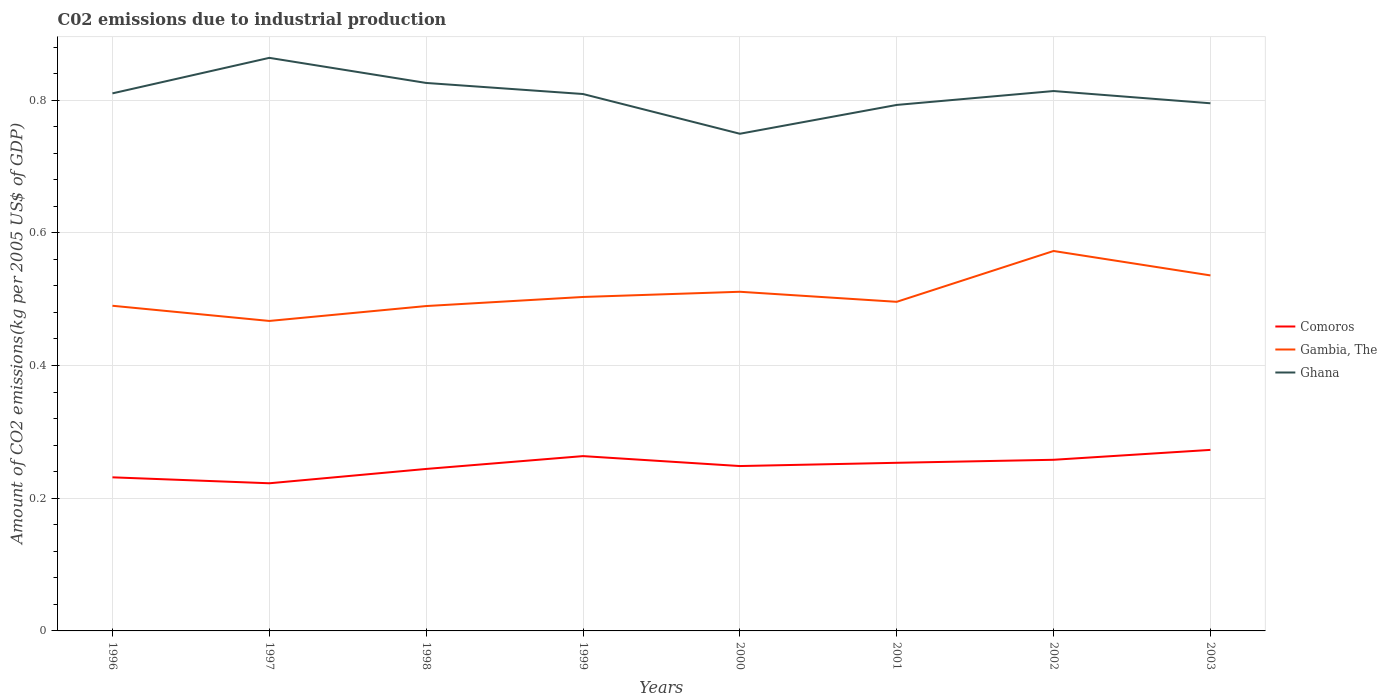How many different coloured lines are there?
Provide a short and direct response. 3. Across all years, what is the maximum amount of CO2 emitted due to industrial production in Ghana?
Give a very brief answer. 0.75. What is the total amount of CO2 emitted due to industrial production in Ghana in the graph?
Provide a succinct answer. -0. What is the difference between the highest and the second highest amount of CO2 emitted due to industrial production in Comoros?
Your response must be concise. 0.05. What is the difference between the highest and the lowest amount of CO2 emitted due to industrial production in Gambia, The?
Ensure brevity in your answer.  3. Does the graph contain grids?
Ensure brevity in your answer.  Yes. How many legend labels are there?
Your answer should be compact. 3. How are the legend labels stacked?
Your answer should be compact. Vertical. What is the title of the graph?
Give a very brief answer. C02 emissions due to industrial production. Does "Tuvalu" appear as one of the legend labels in the graph?
Make the answer very short. No. What is the label or title of the X-axis?
Your answer should be very brief. Years. What is the label or title of the Y-axis?
Keep it short and to the point. Amount of CO2 emissions(kg per 2005 US$ of GDP). What is the Amount of CO2 emissions(kg per 2005 US$ of GDP) in Comoros in 1996?
Offer a terse response. 0.23. What is the Amount of CO2 emissions(kg per 2005 US$ of GDP) in Gambia, The in 1996?
Your answer should be very brief. 0.49. What is the Amount of CO2 emissions(kg per 2005 US$ of GDP) in Ghana in 1996?
Give a very brief answer. 0.81. What is the Amount of CO2 emissions(kg per 2005 US$ of GDP) of Comoros in 1997?
Your answer should be compact. 0.22. What is the Amount of CO2 emissions(kg per 2005 US$ of GDP) of Gambia, The in 1997?
Your answer should be very brief. 0.47. What is the Amount of CO2 emissions(kg per 2005 US$ of GDP) in Ghana in 1997?
Your answer should be compact. 0.86. What is the Amount of CO2 emissions(kg per 2005 US$ of GDP) in Comoros in 1998?
Make the answer very short. 0.24. What is the Amount of CO2 emissions(kg per 2005 US$ of GDP) of Gambia, The in 1998?
Offer a terse response. 0.49. What is the Amount of CO2 emissions(kg per 2005 US$ of GDP) in Ghana in 1998?
Offer a very short reply. 0.83. What is the Amount of CO2 emissions(kg per 2005 US$ of GDP) of Comoros in 1999?
Ensure brevity in your answer.  0.26. What is the Amount of CO2 emissions(kg per 2005 US$ of GDP) of Gambia, The in 1999?
Provide a succinct answer. 0.5. What is the Amount of CO2 emissions(kg per 2005 US$ of GDP) of Ghana in 1999?
Keep it short and to the point. 0.81. What is the Amount of CO2 emissions(kg per 2005 US$ of GDP) in Comoros in 2000?
Keep it short and to the point. 0.25. What is the Amount of CO2 emissions(kg per 2005 US$ of GDP) of Gambia, The in 2000?
Your response must be concise. 0.51. What is the Amount of CO2 emissions(kg per 2005 US$ of GDP) of Ghana in 2000?
Give a very brief answer. 0.75. What is the Amount of CO2 emissions(kg per 2005 US$ of GDP) in Comoros in 2001?
Ensure brevity in your answer.  0.25. What is the Amount of CO2 emissions(kg per 2005 US$ of GDP) in Gambia, The in 2001?
Provide a succinct answer. 0.5. What is the Amount of CO2 emissions(kg per 2005 US$ of GDP) in Ghana in 2001?
Ensure brevity in your answer.  0.79. What is the Amount of CO2 emissions(kg per 2005 US$ of GDP) of Comoros in 2002?
Offer a terse response. 0.26. What is the Amount of CO2 emissions(kg per 2005 US$ of GDP) in Gambia, The in 2002?
Your answer should be compact. 0.57. What is the Amount of CO2 emissions(kg per 2005 US$ of GDP) of Ghana in 2002?
Provide a succinct answer. 0.81. What is the Amount of CO2 emissions(kg per 2005 US$ of GDP) in Comoros in 2003?
Provide a succinct answer. 0.27. What is the Amount of CO2 emissions(kg per 2005 US$ of GDP) of Gambia, The in 2003?
Provide a short and direct response. 0.54. What is the Amount of CO2 emissions(kg per 2005 US$ of GDP) of Ghana in 2003?
Give a very brief answer. 0.8. Across all years, what is the maximum Amount of CO2 emissions(kg per 2005 US$ of GDP) of Comoros?
Provide a succinct answer. 0.27. Across all years, what is the maximum Amount of CO2 emissions(kg per 2005 US$ of GDP) in Gambia, The?
Keep it short and to the point. 0.57. Across all years, what is the maximum Amount of CO2 emissions(kg per 2005 US$ of GDP) of Ghana?
Keep it short and to the point. 0.86. Across all years, what is the minimum Amount of CO2 emissions(kg per 2005 US$ of GDP) of Comoros?
Your answer should be very brief. 0.22. Across all years, what is the minimum Amount of CO2 emissions(kg per 2005 US$ of GDP) of Gambia, The?
Make the answer very short. 0.47. Across all years, what is the minimum Amount of CO2 emissions(kg per 2005 US$ of GDP) of Ghana?
Offer a very short reply. 0.75. What is the total Amount of CO2 emissions(kg per 2005 US$ of GDP) in Comoros in the graph?
Your answer should be very brief. 1.99. What is the total Amount of CO2 emissions(kg per 2005 US$ of GDP) in Gambia, The in the graph?
Keep it short and to the point. 4.07. What is the total Amount of CO2 emissions(kg per 2005 US$ of GDP) of Ghana in the graph?
Offer a terse response. 6.46. What is the difference between the Amount of CO2 emissions(kg per 2005 US$ of GDP) in Comoros in 1996 and that in 1997?
Make the answer very short. 0.01. What is the difference between the Amount of CO2 emissions(kg per 2005 US$ of GDP) in Gambia, The in 1996 and that in 1997?
Your answer should be very brief. 0.02. What is the difference between the Amount of CO2 emissions(kg per 2005 US$ of GDP) of Ghana in 1996 and that in 1997?
Provide a succinct answer. -0.05. What is the difference between the Amount of CO2 emissions(kg per 2005 US$ of GDP) of Comoros in 1996 and that in 1998?
Make the answer very short. -0.01. What is the difference between the Amount of CO2 emissions(kg per 2005 US$ of GDP) of Gambia, The in 1996 and that in 1998?
Offer a terse response. 0. What is the difference between the Amount of CO2 emissions(kg per 2005 US$ of GDP) of Ghana in 1996 and that in 1998?
Provide a succinct answer. -0.02. What is the difference between the Amount of CO2 emissions(kg per 2005 US$ of GDP) of Comoros in 1996 and that in 1999?
Provide a short and direct response. -0.03. What is the difference between the Amount of CO2 emissions(kg per 2005 US$ of GDP) in Gambia, The in 1996 and that in 1999?
Offer a terse response. -0.01. What is the difference between the Amount of CO2 emissions(kg per 2005 US$ of GDP) of Ghana in 1996 and that in 1999?
Ensure brevity in your answer.  0. What is the difference between the Amount of CO2 emissions(kg per 2005 US$ of GDP) in Comoros in 1996 and that in 2000?
Provide a short and direct response. -0.02. What is the difference between the Amount of CO2 emissions(kg per 2005 US$ of GDP) of Gambia, The in 1996 and that in 2000?
Offer a very short reply. -0.02. What is the difference between the Amount of CO2 emissions(kg per 2005 US$ of GDP) in Ghana in 1996 and that in 2000?
Your answer should be compact. 0.06. What is the difference between the Amount of CO2 emissions(kg per 2005 US$ of GDP) in Comoros in 1996 and that in 2001?
Offer a very short reply. -0.02. What is the difference between the Amount of CO2 emissions(kg per 2005 US$ of GDP) of Gambia, The in 1996 and that in 2001?
Provide a short and direct response. -0.01. What is the difference between the Amount of CO2 emissions(kg per 2005 US$ of GDP) in Ghana in 1996 and that in 2001?
Ensure brevity in your answer.  0.02. What is the difference between the Amount of CO2 emissions(kg per 2005 US$ of GDP) of Comoros in 1996 and that in 2002?
Give a very brief answer. -0.03. What is the difference between the Amount of CO2 emissions(kg per 2005 US$ of GDP) of Gambia, The in 1996 and that in 2002?
Give a very brief answer. -0.08. What is the difference between the Amount of CO2 emissions(kg per 2005 US$ of GDP) of Ghana in 1996 and that in 2002?
Your answer should be compact. -0. What is the difference between the Amount of CO2 emissions(kg per 2005 US$ of GDP) in Comoros in 1996 and that in 2003?
Give a very brief answer. -0.04. What is the difference between the Amount of CO2 emissions(kg per 2005 US$ of GDP) in Gambia, The in 1996 and that in 2003?
Provide a short and direct response. -0.05. What is the difference between the Amount of CO2 emissions(kg per 2005 US$ of GDP) of Ghana in 1996 and that in 2003?
Offer a very short reply. 0.01. What is the difference between the Amount of CO2 emissions(kg per 2005 US$ of GDP) in Comoros in 1997 and that in 1998?
Offer a terse response. -0.02. What is the difference between the Amount of CO2 emissions(kg per 2005 US$ of GDP) of Gambia, The in 1997 and that in 1998?
Offer a very short reply. -0.02. What is the difference between the Amount of CO2 emissions(kg per 2005 US$ of GDP) of Ghana in 1997 and that in 1998?
Provide a short and direct response. 0.04. What is the difference between the Amount of CO2 emissions(kg per 2005 US$ of GDP) of Comoros in 1997 and that in 1999?
Ensure brevity in your answer.  -0.04. What is the difference between the Amount of CO2 emissions(kg per 2005 US$ of GDP) of Gambia, The in 1997 and that in 1999?
Provide a succinct answer. -0.04. What is the difference between the Amount of CO2 emissions(kg per 2005 US$ of GDP) of Ghana in 1997 and that in 1999?
Your answer should be compact. 0.05. What is the difference between the Amount of CO2 emissions(kg per 2005 US$ of GDP) of Comoros in 1997 and that in 2000?
Your response must be concise. -0.03. What is the difference between the Amount of CO2 emissions(kg per 2005 US$ of GDP) of Gambia, The in 1997 and that in 2000?
Provide a succinct answer. -0.04. What is the difference between the Amount of CO2 emissions(kg per 2005 US$ of GDP) in Ghana in 1997 and that in 2000?
Offer a terse response. 0.11. What is the difference between the Amount of CO2 emissions(kg per 2005 US$ of GDP) in Comoros in 1997 and that in 2001?
Provide a succinct answer. -0.03. What is the difference between the Amount of CO2 emissions(kg per 2005 US$ of GDP) in Gambia, The in 1997 and that in 2001?
Offer a terse response. -0.03. What is the difference between the Amount of CO2 emissions(kg per 2005 US$ of GDP) in Ghana in 1997 and that in 2001?
Keep it short and to the point. 0.07. What is the difference between the Amount of CO2 emissions(kg per 2005 US$ of GDP) in Comoros in 1997 and that in 2002?
Keep it short and to the point. -0.04. What is the difference between the Amount of CO2 emissions(kg per 2005 US$ of GDP) of Gambia, The in 1997 and that in 2002?
Your answer should be compact. -0.11. What is the difference between the Amount of CO2 emissions(kg per 2005 US$ of GDP) of Ghana in 1997 and that in 2002?
Give a very brief answer. 0.05. What is the difference between the Amount of CO2 emissions(kg per 2005 US$ of GDP) in Comoros in 1997 and that in 2003?
Make the answer very short. -0.05. What is the difference between the Amount of CO2 emissions(kg per 2005 US$ of GDP) of Gambia, The in 1997 and that in 2003?
Your answer should be compact. -0.07. What is the difference between the Amount of CO2 emissions(kg per 2005 US$ of GDP) of Ghana in 1997 and that in 2003?
Your answer should be compact. 0.07. What is the difference between the Amount of CO2 emissions(kg per 2005 US$ of GDP) of Comoros in 1998 and that in 1999?
Offer a very short reply. -0.02. What is the difference between the Amount of CO2 emissions(kg per 2005 US$ of GDP) in Gambia, The in 1998 and that in 1999?
Offer a terse response. -0.01. What is the difference between the Amount of CO2 emissions(kg per 2005 US$ of GDP) in Ghana in 1998 and that in 1999?
Offer a terse response. 0.02. What is the difference between the Amount of CO2 emissions(kg per 2005 US$ of GDP) of Comoros in 1998 and that in 2000?
Ensure brevity in your answer.  -0. What is the difference between the Amount of CO2 emissions(kg per 2005 US$ of GDP) of Gambia, The in 1998 and that in 2000?
Make the answer very short. -0.02. What is the difference between the Amount of CO2 emissions(kg per 2005 US$ of GDP) in Ghana in 1998 and that in 2000?
Ensure brevity in your answer.  0.08. What is the difference between the Amount of CO2 emissions(kg per 2005 US$ of GDP) of Comoros in 1998 and that in 2001?
Keep it short and to the point. -0.01. What is the difference between the Amount of CO2 emissions(kg per 2005 US$ of GDP) of Gambia, The in 1998 and that in 2001?
Make the answer very short. -0.01. What is the difference between the Amount of CO2 emissions(kg per 2005 US$ of GDP) of Ghana in 1998 and that in 2001?
Ensure brevity in your answer.  0.03. What is the difference between the Amount of CO2 emissions(kg per 2005 US$ of GDP) of Comoros in 1998 and that in 2002?
Offer a terse response. -0.01. What is the difference between the Amount of CO2 emissions(kg per 2005 US$ of GDP) in Gambia, The in 1998 and that in 2002?
Offer a very short reply. -0.08. What is the difference between the Amount of CO2 emissions(kg per 2005 US$ of GDP) in Ghana in 1998 and that in 2002?
Keep it short and to the point. 0.01. What is the difference between the Amount of CO2 emissions(kg per 2005 US$ of GDP) of Comoros in 1998 and that in 2003?
Keep it short and to the point. -0.03. What is the difference between the Amount of CO2 emissions(kg per 2005 US$ of GDP) in Gambia, The in 1998 and that in 2003?
Ensure brevity in your answer.  -0.05. What is the difference between the Amount of CO2 emissions(kg per 2005 US$ of GDP) in Ghana in 1998 and that in 2003?
Offer a terse response. 0.03. What is the difference between the Amount of CO2 emissions(kg per 2005 US$ of GDP) of Comoros in 1999 and that in 2000?
Keep it short and to the point. 0.01. What is the difference between the Amount of CO2 emissions(kg per 2005 US$ of GDP) of Gambia, The in 1999 and that in 2000?
Your response must be concise. -0.01. What is the difference between the Amount of CO2 emissions(kg per 2005 US$ of GDP) of Ghana in 1999 and that in 2000?
Offer a very short reply. 0.06. What is the difference between the Amount of CO2 emissions(kg per 2005 US$ of GDP) in Comoros in 1999 and that in 2001?
Provide a short and direct response. 0.01. What is the difference between the Amount of CO2 emissions(kg per 2005 US$ of GDP) in Gambia, The in 1999 and that in 2001?
Your answer should be compact. 0.01. What is the difference between the Amount of CO2 emissions(kg per 2005 US$ of GDP) in Ghana in 1999 and that in 2001?
Provide a short and direct response. 0.02. What is the difference between the Amount of CO2 emissions(kg per 2005 US$ of GDP) of Comoros in 1999 and that in 2002?
Make the answer very short. 0.01. What is the difference between the Amount of CO2 emissions(kg per 2005 US$ of GDP) of Gambia, The in 1999 and that in 2002?
Offer a very short reply. -0.07. What is the difference between the Amount of CO2 emissions(kg per 2005 US$ of GDP) in Ghana in 1999 and that in 2002?
Your answer should be compact. -0. What is the difference between the Amount of CO2 emissions(kg per 2005 US$ of GDP) of Comoros in 1999 and that in 2003?
Give a very brief answer. -0.01. What is the difference between the Amount of CO2 emissions(kg per 2005 US$ of GDP) in Gambia, The in 1999 and that in 2003?
Ensure brevity in your answer.  -0.03. What is the difference between the Amount of CO2 emissions(kg per 2005 US$ of GDP) in Ghana in 1999 and that in 2003?
Provide a succinct answer. 0.01. What is the difference between the Amount of CO2 emissions(kg per 2005 US$ of GDP) in Comoros in 2000 and that in 2001?
Offer a very short reply. -0. What is the difference between the Amount of CO2 emissions(kg per 2005 US$ of GDP) of Gambia, The in 2000 and that in 2001?
Keep it short and to the point. 0.02. What is the difference between the Amount of CO2 emissions(kg per 2005 US$ of GDP) of Ghana in 2000 and that in 2001?
Your answer should be very brief. -0.04. What is the difference between the Amount of CO2 emissions(kg per 2005 US$ of GDP) in Comoros in 2000 and that in 2002?
Your response must be concise. -0.01. What is the difference between the Amount of CO2 emissions(kg per 2005 US$ of GDP) in Gambia, The in 2000 and that in 2002?
Provide a short and direct response. -0.06. What is the difference between the Amount of CO2 emissions(kg per 2005 US$ of GDP) in Ghana in 2000 and that in 2002?
Your answer should be compact. -0.06. What is the difference between the Amount of CO2 emissions(kg per 2005 US$ of GDP) of Comoros in 2000 and that in 2003?
Your answer should be very brief. -0.02. What is the difference between the Amount of CO2 emissions(kg per 2005 US$ of GDP) of Gambia, The in 2000 and that in 2003?
Your response must be concise. -0.02. What is the difference between the Amount of CO2 emissions(kg per 2005 US$ of GDP) of Ghana in 2000 and that in 2003?
Offer a terse response. -0.05. What is the difference between the Amount of CO2 emissions(kg per 2005 US$ of GDP) in Comoros in 2001 and that in 2002?
Keep it short and to the point. -0. What is the difference between the Amount of CO2 emissions(kg per 2005 US$ of GDP) of Gambia, The in 2001 and that in 2002?
Your answer should be very brief. -0.08. What is the difference between the Amount of CO2 emissions(kg per 2005 US$ of GDP) in Ghana in 2001 and that in 2002?
Ensure brevity in your answer.  -0.02. What is the difference between the Amount of CO2 emissions(kg per 2005 US$ of GDP) in Comoros in 2001 and that in 2003?
Provide a short and direct response. -0.02. What is the difference between the Amount of CO2 emissions(kg per 2005 US$ of GDP) in Gambia, The in 2001 and that in 2003?
Provide a succinct answer. -0.04. What is the difference between the Amount of CO2 emissions(kg per 2005 US$ of GDP) of Ghana in 2001 and that in 2003?
Offer a very short reply. -0. What is the difference between the Amount of CO2 emissions(kg per 2005 US$ of GDP) in Comoros in 2002 and that in 2003?
Give a very brief answer. -0.01. What is the difference between the Amount of CO2 emissions(kg per 2005 US$ of GDP) of Gambia, The in 2002 and that in 2003?
Give a very brief answer. 0.04. What is the difference between the Amount of CO2 emissions(kg per 2005 US$ of GDP) in Ghana in 2002 and that in 2003?
Keep it short and to the point. 0.02. What is the difference between the Amount of CO2 emissions(kg per 2005 US$ of GDP) of Comoros in 1996 and the Amount of CO2 emissions(kg per 2005 US$ of GDP) of Gambia, The in 1997?
Provide a short and direct response. -0.24. What is the difference between the Amount of CO2 emissions(kg per 2005 US$ of GDP) in Comoros in 1996 and the Amount of CO2 emissions(kg per 2005 US$ of GDP) in Ghana in 1997?
Make the answer very short. -0.63. What is the difference between the Amount of CO2 emissions(kg per 2005 US$ of GDP) in Gambia, The in 1996 and the Amount of CO2 emissions(kg per 2005 US$ of GDP) in Ghana in 1997?
Your response must be concise. -0.37. What is the difference between the Amount of CO2 emissions(kg per 2005 US$ of GDP) in Comoros in 1996 and the Amount of CO2 emissions(kg per 2005 US$ of GDP) in Gambia, The in 1998?
Provide a short and direct response. -0.26. What is the difference between the Amount of CO2 emissions(kg per 2005 US$ of GDP) in Comoros in 1996 and the Amount of CO2 emissions(kg per 2005 US$ of GDP) in Ghana in 1998?
Your answer should be compact. -0.59. What is the difference between the Amount of CO2 emissions(kg per 2005 US$ of GDP) of Gambia, The in 1996 and the Amount of CO2 emissions(kg per 2005 US$ of GDP) of Ghana in 1998?
Ensure brevity in your answer.  -0.34. What is the difference between the Amount of CO2 emissions(kg per 2005 US$ of GDP) in Comoros in 1996 and the Amount of CO2 emissions(kg per 2005 US$ of GDP) in Gambia, The in 1999?
Ensure brevity in your answer.  -0.27. What is the difference between the Amount of CO2 emissions(kg per 2005 US$ of GDP) in Comoros in 1996 and the Amount of CO2 emissions(kg per 2005 US$ of GDP) in Ghana in 1999?
Provide a short and direct response. -0.58. What is the difference between the Amount of CO2 emissions(kg per 2005 US$ of GDP) of Gambia, The in 1996 and the Amount of CO2 emissions(kg per 2005 US$ of GDP) of Ghana in 1999?
Keep it short and to the point. -0.32. What is the difference between the Amount of CO2 emissions(kg per 2005 US$ of GDP) of Comoros in 1996 and the Amount of CO2 emissions(kg per 2005 US$ of GDP) of Gambia, The in 2000?
Keep it short and to the point. -0.28. What is the difference between the Amount of CO2 emissions(kg per 2005 US$ of GDP) of Comoros in 1996 and the Amount of CO2 emissions(kg per 2005 US$ of GDP) of Ghana in 2000?
Give a very brief answer. -0.52. What is the difference between the Amount of CO2 emissions(kg per 2005 US$ of GDP) in Gambia, The in 1996 and the Amount of CO2 emissions(kg per 2005 US$ of GDP) in Ghana in 2000?
Give a very brief answer. -0.26. What is the difference between the Amount of CO2 emissions(kg per 2005 US$ of GDP) of Comoros in 1996 and the Amount of CO2 emissions(kg per 2005 US$ of GDP) of Gambia, The in 2001?
Your response must be concise. -0.26. What is the difference between the Amount of CO2 emissions(kg per 2005 US$ of GDP) of Comoros in 1996 and the Amount of CO2 emissions(kg per 2005 US$ of GDP) of Ghana in 2001?
Ensure brevity in your answer.  -0.56. What is the difference between the Amount of CO2 emissions(kg per 2005 US$ of GDP) in Gambia, The in 1996 and the Amount of CO2 emissions(kg per 2005 US$ of GDP) in Ghana in 2001?
Offer a very short reply. -0.3. What is the difference between the Amount of CO2 emissions(kg per 2005 US$ of GDP) of Comoros in 1996 and the Amount of CO2 emissions(kg per 2005 US$ of GDP) of Gambia, The in 2002?
Your response must be concise. -0.34. What is the difference between the Amount of CO2 emissions(kg per 2005 US$ of GDP) of Comoros in 1996 and the Amount of CO2 emissions(kg per 2005 US$ of GDP) of Ghana in 2002?
Keep it short and to the point. -0.58. What is the difference between the Amount of CO2 emissions(kg per 2005 US$ of GDP) in Gambia, The in 1996 and the Amount of CO2 emissions(kg per 2005 US$ of GDP) in Ghana in 2002?
Offer a very short reply. -0.32. What is the difference between the Amount of CO2 emissions(kg per 2005 US$ of GDP) in Comoros in 1996 and the Amount of CO2 emissions(kg per 2005 US$ of GDP) in Gambia, The in 2003?
Offer a very short reply. -0.3. What is the difference between the Amount of CO2 emissions(kg per 2005 US$ of GDP) in Comoros in 1996 and the Amount of CO2 emissions(kg per 2005 US$ of GDP) in Ghana in 2003?
Keep it short and to the point. -0.56. What is the difference between the Amount of CO2 emissions(kg per 2005 US$ of GDP) of Gambia, The in 1996 and the Amount of CO2 emissions(kg per 2005 US$ of GDP) of Ghana in 2003?
Provide a short and direct response. -0.31. What is the difference between the Amount of CO2 emissions(kg per 2005 US$ of GDP) in Comoros in 1997 and the Amount of CO2 emissions(kg per 2005 US$ of GDP) in Gambia, The in 1998?
Provide a short and direct response. -0.27. What is the difference between the Amount of CO2 emissions(kg per 2005 US$ of GDP) in Comoros in 1997 and the Amount of CO2 emissions(kg per 2005 US$ of GDP) in Ghana in 1998?
Ensure brevity in your answer.  -0.6. What is the difference between the Amount of CO2 emissions(kg per 2005 US$ of GDP) of Gambia, The in 1997 and the Amount of CO2 emissions(kg per 2005 US$ of GDP) of Ghana in 1998?
Offer a terse response. -0.36. What is the difference between the Amount of CO2 emissions(kg per 2005 US$ of GDP) in Comoros in 1997 and the Amount of CO2 emissions(kg per 2005 US$ of GDP) in Gambia, The in 1999?
Your answer should be very brief. -0.28. What is the difference between the Amount of CO2 emissions(kg per 2005 US$ of GDP) in Comoros in 1997 and the Amount of CO2 emissions(kg per 2005 US$ of GDP) in Ghana in 1999?
Ensure brevity in your answer.  -0.59. What is the difference between the Amount of CO2 emissions(kg per 2005 US$ of GDP) of Gambia, The in 1997 and the Amount of CO2 emissions(kg per 2005 US$ of GDP) of Ghana in 1999?
Make the answer very short. -0.34. What is the difference between the Amount of CO2 emissions(kg per 2005 US$ of GDP) of Comoros in 1997 and the Amount of CO2 emissions(kg per 2005 US$ of GDP) of Gambia, The in 2000?
Your answer should be compact. -0.29. What is the difference between the Amount of CO2 emissions(kg per 2005 US$ of GDP) of Comoros in 1997 and the Amount of CO2 emissions(kg per 2005 US$ of GDP) of Ghana in 2000?
Give a very brief answer. -0.53. What is the difference between the Amount of CO2 emissions(kg per 2005 US$ of GDP) in Gambia, The in 1997 and the Amount of CO2 emissions(kg per 2005 US$ of GDP) in Ghana in 2000?
Your response must be concise. -0.28. What is the difference between the Amount of CO2 emissions(kg per 2005 US$ of GDP) in Comoros in 1997 and the Amount of CO2 emissions(kg per 2005 US$ of GDP) in Gambia, The in 2001?
Provide a succinct answer. -0.27. What is the difference between the Amount of CO2 emissions(kg per 2005 US$ of GDP) of Comoros in 1997 and the Amount of CO2 emissions(kg per 2005 US$ of GDP) of Ghana in 2001?
Offer a very short reply. -0.57. What is the difference between the Amount of CO2 emissions(kg per 2005 US$ of GDP) of Gambia, The in 1997 and the Amount of CO2 emissions(kg per 2005 US$ of GDP) of Ghana in 2001?
Offer a very short reply. -0.33. What is the difference between the Amount of CO2 emissions(kg per 2005 US$ of GDP) in Comoros in 1997 and the Amount of CO2 emissions(kg per 2005 US$ of GDP) in Gambia, The in 2002?
Ensure brevity in your answer.  -0.35. What is the difference between the Amount of CO2 emissions(kg per 2005 US$ of GDP) in Comoros in 1997 and the Amount of CO2 emissions(kg per 2005 US$ of GDP) in Ghana in 2002?
Your response must be concise. -0.59. What is the difference between the Amount of CO2 emissions(kg per 2005 US$ of GDP) in Gambia, The in 1997 and the Amount of CO2 emissions(kg per 2005 US$ of GDP) in Ghana in 2002?
Offer a terse response. -0.35. What is the difference between the Amount of CO2 emissions(kg per 2005 US$ of GDP) in Comoros in 1997 and the Amount of CO2 emissions(kg per 2005 US$ of GDP) in Gambia, The in 2003?
Keep it short and to the point. -0.31. What is the difference between the Amount of CO2 emissions(kg per 2005 US$ of GDP) of Comoros in 1997 and the Amount of CO2 emissions(kg per 2005 US$ of GDP) of Ghana in 2003?
Provide a short and direct response. -0.57. What is the difference between the Amount of CO2 emissions(kg per 2005 US$ of GDP) in Gambia, The in 1997 and the Amount of CO2 emissions(kg per 2005 US$ of GDP) in Ghana in 2003?
Your answer should be compact. -0.33. What is the difference between the Amount of CO2 emissions(kg per 2005 US$ of GDP) in Comoros in 1998 and the Amount of CO2 emissions(kg per 2005 US$ of GDP) in Gambia, The in 1999?
Your answer should be very brief. -0.26. What is the difference between the Amount of CO2 emissions(kg per 2005 US$ of GDP) in Comoros in 1998 and the Amount of CO2 emissions(kg per 2005 US$ of GDP) in Ghana in 1999?
Make the answer very short. -0.56. What is the difference between the Amount of CO2 emissions(kg per 2005 US$ of GDP) in Gambia, The in 1998 and the Amount of CO2 emissions(kg per 2005 US$ of GDP) in Ghana in 1999?
Provide a short and direct response. -0.32. What is the difference between the Amount of CO2 emissions(kg per 2005 US$ of GDP) of Comoros in 1998 and the Amount of CO2 emissions(kg per 2005 US$ of GDP) of Gambia, The in 2000?
Give a very brief answer. -0.27. What is the difference between the Amount of CO2 emissions(kg per 2005 US$ of GDP) of Comoros in 1998 and the Amount of CO2 emissions(kg per 2005 US$ of GDP) of Ghana in 2000?
Ensure brevity in your answer.  -0.51. What is the difference between the Amount of CO2 emissions(kg per 2005 US$ of GDP) in Gambia, The in 1998 and the Amount of CO2 emissions(kg per 2005 US$ of GDP) in Ghana in 2000?
Ensure brevity in your answer.  -0.26. What is the difference between the Amount of CO2 emissions(kg per 2005 US$ of GDP) of Comoros in 1998 and the Amount of CO2 emissions(kg per 2005 US$ of GDP) of Gambia, The in 2001?
Offer a very short reply. -0.25. What is the difference between the Amount of CO2 emissions(kg per 2005 US$ of GDP) of Comoros in 1998 and the Amount of CO2 emissions(kg per 2005 US$ of GDP) of Ghana in 2001?
Provide a succinct answer. -0.55. What is the difference between the Amount of CO2 emissions(kg per 2005 US$ of GDP) in Gambia, The in 1998 and the Amount of CO2 emissions(kg per 2005 US$ of GDP) in Ghana in 2001?
Your response must be concise. -0.3. What is the difference between the Amount of CO2 emissions(kg per 2005 US$ of GDP) of Comoros in 1998 and the Amount of CO2 emissions(kg per 2005 US$ of GDP) of Gambia, The in 2002?
Provide a succinct answer. -0.33. What is the difference between the Amount of CO2 emissions(kg per 2005 US$ of GDP) of Comoros in 1998 and the Amount of CO2 emissions(kg per 2005 US$ of GDP) of Ghana in 2002?
Provide a succinct answer. -0.57. What is the difference between the Amount of CO2 emissions(kg per 2005 US$ of GDP) of Gambia, The in 1998 and the Amount of CO2 emissions(kg per 2005 US$ of GDP) of Ghana in 2002?
Your answer should be compact. -0.32. What is the difference between the Amount of CO2 emissions(kg per 2005 US$ of GDP) in Comoros in 1998 and the Amount of CO2 emissions(kg per 2005 US$ of GDP) in Gambia, The in 2003?
Provide a succinct answer. -0.29. What is the difference between the Amount of CO2 emissions(kg per 2005 US$ of GDP) of Comoros in 1998 and the Amount of CO2 emissions(kg per 2005 US$ of GDP) of Ghana in 2003?
Keep it short and to the point. -0.55. What is the difference between the Amount of CO2 emissions(kg per 2005 US$ of GDP) in Gambia, The in 1998 and the Amount of CO2 emissions(kg per 2005 US$ of GDP) in Ghana in 2003?
Ensure brevity in your answer.  -0.31. What is the difference between the Amount of CO2 emissions(kg per 2005 US$ of GDP) in Comoros in 1999 and the Amount of CO2 emissions(kg per 2005 US$ of GDP) in Gambia, The in 2000?
Keep it short and to the point. -0.25. What is the difference between the Amount of CO2 emissions(kg per 2005 US$ of GDP) in Comoros in 1999 and the Amount of CO2 emissions(kg per 2005 US$ of GDP) in Ghana in 2000?
Your response must be concise. -0.49. What is the difference between the Amount of CO2 emissions(kg per 2005 US$ of GDP) in Gambia, The in 1999 and the Amount of CO2 emissions(kg per 2005 US$ of GDP) in Ghana in 2000?
Offer a terse response. -0.25. What is the difference between the Amount of CO2 emissions(kg per 2005 US$ of GDP) of Comoros in 1999 and the Amount of CO2 emissions(kg per 2005 US$ of GDP) of Gambia, The in 2001?
Keep it short and to the point. -0.23. What is the difference between the Amount of CO2 emissions(kg per 2005 US$ of GDP) of Comoros in 1999 and the Amount of CO2 emissions(kg per 2005 US$ of GDP) of Ghana in 2001?
Ensure brevity in your answer.  -0.53. What is the difference between the Amount of CO2 emissions(kg per 2005 US$ of GDP) in Gambia, The in 1999 and the Amount of CO2 emissions(kg per 2005 US$ of GDP) in Ghana in 2001?
Your answer should be compact. -0.29. What is the difference between the Amount of CO2 emissions(kg per 2005 US$ of GDP) in Comoros in 1999 and the Amount of CO2 emissions(kg per 2005 US$ of GDP) in Gambia, The in 2002?
Your response must be concise. -0.31. What is the difference between the Amount of CO2 emissions(kg per 2005 US$ of GDP) of Comoros in 1999 and the Amount of CO2 emissions(kg per 2005 US$ of GDP) of Ghana in 2002?
Offer a terse response. -0.55. What is the difference between the Amount of CO2 emissions(kg per 2005 US$ of GDP) of Gambia, The in 1999 and the Amount of CO2 emissions(kg per 2005 US$ of GDP) of Ghana in 2002?
Provide a short and direct response. -0.31. What is the difference between the Amount of CO2 emissions(kg per 2005 US$ of GDP) of Comoros in 1999 and the Amount of CO2 emissions(kg per 2005 US$ of GDP) of Gambia, The in 2003?
Make the answer very short. -0.27. What is the difference between the Amount of CO2 emissions(kg per 2005 US$ of GDP) of Comoros in 1999 and the Amount of CO2 emissions(kg per 2005 US$ of GDP) of Ghana in 2003?
Offer a very short reply. -0.53. What is the difference between the Amount of CO2 emissions(kg per 2005 US$ of GDP) in Gambia, The in 1999 and the Amount of CO2 emissions(kg per 2005 US$ of GDP) in Ghana in 2003?
Your answer should be compact. -0.29. What is the difference between the Amount of CO2 emissions(kg per 2005 US$ of GDP) in Comoros in 2000 and the Amount of CO2 emissions(kg per 2005 US$ of GDP) in Gambia, The in 2001?
Ensure brevity in your answer.  -0.25. What is the difference between the Amount of CO2 emissions(kg per 2005 US$ of GDP) of Comoros in 2000 and the Amount of CO2 emissions(kg per 2005 US$ of GDP) of Ghana in 2001?
Make the answer very short. -0.54. What is the difference between the Amount of CO2 emissions(kg per 2005 US$ of GDP) in Gambia, The in 2000 and the Amount of CO2 emissions(kg per 2005 US$ of GDP) in Ghana in 2001?
Offer a terse response. -0.28. What is the difference between the Amount of CO2 emissions(kg per 2005 US$ of GDP) in Comoros in 2000 and the Amount of CO2 emissions(kg per 2005 US$ of GDP) in Gambia, The in 2002?
Provide a short and direct response. -0.32. What is the difference between the Amount of CO2 emissions(kg per 2005 US$ of GDP) in Comoros in 2000 and the Amount of CO2 emissions(kg per 2005 US$ of GDP) in Ghana in 2002?
Your response must be concise. -0.57. What is the difference between the Amount of CO2 emissions(kg per 2005 US$ of GDP) of Gambia, The in 2000 and the Amount of CO2 emissions(kg per 2005 US$ of GDP) of Ghana in 2002?
Offer a terse response. -0.3. What is the difference between the Amount of CO2 emissions(kg per 2005 US$ of GDP) in Comoros in 2000 and the Amount of CO2 emissions(kg per 2005 US$ of GDP) in Gambia, The in 2003?
Your answer should be very brief. -0.29. What is the difference between the Amount of CO2 emissions(kg per 2005 US$ of GDP) in Comoros in 2000 and the Amount of CO2 emissions(kg per 2005 US$ of GDP) in Ghana in 2003?
Give a very brief answer. -0.55. What is the difference between the Amount of CO2 emissions(kg per 2005 US$ of GDP) in Gambia, The in 2000 and the Amount of CO2 emissions(kg per 2005 US$ of GDP) in Ghana in 2003?
Provide a short and direct response. -0.28. What is the difference between the Amount of CO2 emissions(kg per 2005 US$ of GDP) in Comoros in 2001 and the Amount of CO2 emissions(kg per 2005 US$ of GDP) in Gambia, The in 2002?
Offer a terse response. -0.32. What is the difference between the Amount of CO2 emissions(kg per 2005 US$ of GDP) in Comoros in 2001 and the Amount of CO2 emissions(kg per 2005 US$ of GDP) in Ghana in 2002?
Give a very brief answer. -0.56. What is the difference between the Amount of CO2 emissions(kg per 2005 US$ of GDP) of Gambia, The in 2001 and the Amount of CO2 emissions(kg per 2005 US$ of GDP) of Ghana in 2002?
Provide a succinct answer. -0.32. What is the difference between the Amount of CO2 emissions(kg per 2005 US$ of GDP) of Comoros in 2001 and the Amount of CO2 emissions(kg per 2005 US$ of GDP) of Gambia, The in 2003?
Give a very brief answer. -0.28. What is the difference between the Amount of CO2 emissions(kg per 2005 US$ of GDP) in Comoros in 2001 and the Amount of CO2 emissions(kg per 2005 US$ of GDP) in Ghana in 2003?
Your answer should be compact. -0.54. What is the difference between the Amount of CO2 emissions(kg per 2005 US$ of GDP) in Gambia, The in 2001 and the Amount of CO2 emissions(kg per 2005 US$ of GDP) in Ghana in 2003?
Offer a very short reply. -0.3. What is the difference between the Amount of CO2 emissions(kg per 2005 US$ of GDP) of Comoros in 2002 and the Amount of CO2 emissions(kg per 2005 US$ of GDP) of Gambia, The in 2003?
Provide a succinct answer. -0.28. What is the difference between the Amount of CO2 emissions(kg per 2005 US$ of GDP) of Comoros in 2002 and the Amount of CO2 emissions(kg per 2005 US$ of GDP) of Ghana in 2003?
Give a very brief answer. -0.54. What is the difference between the Amount of CO2 emissions(kg per 2005 US$ of GDP) in Gambia, The in 2002 and the Amount of CO2 emissions(kg per 2005 US$ of GDP) in Ghana in 2003?
Offer a terse response. -0.22. What is the average Amount of CO2 emissions(kg per 2005 US$ of GDP) in Comoros per year?
Your answer should be very brief. 0.25. What is the average Amount of CO2 emissions(kg per 2005 US$ of GDP) in Gambia, The per year?
Offer a terse response. 0.51. What is the average Amount of CO2 emissions(kg per 2005 US$ of GDP) in Ghana per year?
Your response must be concise. 0.81. In the year 1996, what is the difference between the Amount of CO2 emissions(kg per 2005 US$ of GDP) of Comoros and Amount of CO2 emissions(kg per 2005 US$ of GDP) of Gambia, The?
Give a very brief answer. -0.26. In the year 1996, what is the difference between the Amount of CO2 emissions(kg per 2005 US$ of GDP) in Comoros and Amount of CO2 emissions(kg per 2005 US$ of GDP) in Ghana?
Give a very brief answer. -0.58. In the year 1996, what is the difference between the Amount of CO2 emissions(kg per 2005 US$ of GDP) of Gambia, The and Amount of CO2 emissions(kg per 2005 US$ of GDP) of Ghana?
Give a very brief answer. -0.32. In the year 1997, what is the difference between the Amount of CO2 emissions(kg per 2005 US$ of GDP) in Comoros and Amount of CO2 emissions(kg per 2005 US$ of GDP) in Gambia, The?
Keep it short and to the point. -0.24. In the year 1997, what is the difference between the Amount of CO2 emissions(kg per 2005 US$ of GDP) in Comoros and Amount of CO2 emissions(kg per 2005 US$ of GDP) in Ghana?
Your response must be concise. -0.64. In the year 1997, what is the difference between the Amount of CO2 emissions(kg per 2005 US$ of GDP) in Gambia, The and Amount of CO2 emissions(kg per 2005 US$ of GDP) in Ghana?
Provide a short and direct response. -0.4. In the year 1998, what is the difference between the Amount of CO2 emissions(kg per 2005 US$ of GDP) of Comoros and Amount of CO2 emissions(kg per 2005 US$ of GDP) of Gambia, The?
Provide a succinct answer. -0.25. In the year 1998, what is the difference between the Amount of CO2 emissions(kg per 2005 US$ of GDP) in Comoros and Amount of CO2 emissions(kg per 2005 US$ of GDP) in Ghana?
Make the answer very short. -0.58. In the year 1998, what is the difference between the Amount of CO2 emissions(kg per 2005 US$ of GDP) of Gambia, The and Amount of CO2 emissions(kg per 2005 US$ of GDP) of Ghana?
Your response must be concise. -0.34. In the year 1999, what is the difference between the Amount of CO2 emissions(kg per 2005 US$ of GDP) in Comoros and Amount of CO2 emissions(kg per 2005 US$ of GDP) in Gambia, The?
Provide a short and direct response. -0.24. In the year 1999, what is the difference between the Amount of CO2 emissions(kg per 2005 US$ of GDP) in Comoros and Amount of CO2 emissions(kg per 2005 US$ of GDP) in Ghana?
Ensure brevity in your answer.  -0.55. In the year 1999, what is the difference between the Amount of CO2 emissions(kg per 2005 US$ of GDP) in Gambia, The and Amount of CO2 emissions(kg per 2005 US$ of GDP) in Ghana?
Offer a terse response. -0.31. In the year 2000, what is the difference between the Amount of CO2 emissions(kg per 2005 US$ of GDP) of Comoros and Amount of CO2 emissions(kg per 2005 US$ of GDP) of Gambia, The?
Your answer should be very brief. -0.26. In the year 2000, what is the difference between the Amount of CO2 emissions(kg per 2005 US$ of GDP) of Comoros and Amount of CO2 emissions(kg per 2005 US$ of GDP) of Ghana?
Your answer should be compact. -0.5. In the year 2000, what is the difference between the Amount of CO2 emissions(kg per 2005 US$ of GDP) in Gambia, The and Amount of CO2 emissions(kg per 2005 US$ of GDP) in Ghana?
Keep it short and to the point. -0.24. In the year 2001, what is the difference between the Amount of CO2 emissions(kg per 2005 US$ of GDP) of Comoros and Amount of CO2 emissions(kg per 2005 US$ of GDP) of Gambia, The?
Make the answer very short. -0.24. In the year 2001, what is the difference between the Amount of CO2 emissions(kg per 2005 US$ of GDP) of Comoros and Amount of CO2 emissions(kg per 2005 US$ of GDP) of Ghana?
Provide a short and direct response. -0.54. In the year 2001, what is the difference between the Amount of CO2 emissions(kg per 2005 US$ of GDP) of Gambia, The and Amount of CO2 emissions(kg per 2005 US$ of GDP) of Ghana?
Offer a very short reply. -0.3. In the year 2002, what is the difference between the Amount of CO2 emissions(kg per 2005 US$ of GDP) of Comoros and Amount of CO2 emissions(kg per 2005 US$ of GDP) of Gambia, The?
Provide a short and direct response. -0.31. In the year 2002, what is the difference between the Amount of CO2 emissions(kg per 2005 US$ of GDP) of Comoros and Amount of CO2 emissions(kg per 2005 US$ of GDP) of Ghana?
Provide a succinct answer. -0.56. In the year 2002, what is the difference between the Amount of CO2 emissions(kg per 2005 US$ of GDP) in Gambia, The and Amount of CO2 emissions(kg per 2005 US$ of GDP) in Ghana?
Your answer should be very brief. -0.24. In the year 2003, what is the difference between the Amount of CO2 emissions(kg per 2005 US$ of GDP) of Comoros and Amount of CO2 emissions(kg per 2005 US$ of GDP) of Gambia, The?
Provide a short and direct response. -0.26. In the year 2003, what is the difference between the Amount of CO2 emissions(kg per 2005 US$ of GDP) in Comoros and Amount of CO2 emissions(kg per 2005 US$ of GDP) in Ghana?
Your answer should be compact. -0.52. In the year 2003, what is the difference between the Amount of CO2 emissions(kg per 2005 US$ of GDP) in Gambia, The and Amount of CO2 emissions(kg per 2005 US$ of GDP) in Ghana?
Your response must be concise. -0.26. What is the ratio of the Amount of CO2 emissions(kg per 2005 US$ of GDP) in Comoros in 1996 to that in 1997?
Keep it short and to the point. 1.04. What is the ratio of the Amount of CO2 emissions(kg per 2005 US$ of GDP) in Gambia, The in 1996 to that in 1997?
Ensure brevity in your answer.  1.05. What is the ratio of the Amount of CO2 emissions(kg per 2005 US$ of GDP) of Ghana in 1996 to that in 1997?
Keep it short and to the point. 0.94. What is the ratio of the Amount of CO2 emissions(kg per 2005 US$ of GDP) of Comoros in 1996 to that in 1998?
Make the answer very short. 0.95. What is the ratio of the Amount of CO2 emissions(kg per 2005 US$ of GDP) of Comoros in 1996 to that in 1999?
Make the answer very short. 0.88. What is the ratio of the Amount of CO2 emissions(kg per 2005 US$ of GDP) in Gambia, The in 1996 to that in 1999?
Your response must be concise. 0.97. What is the ratio of the Amount of CO2 emissions(kg per 2005 US$ of GDP) of Comoros in 1996 to that in 2000?
Give a very brief answer. 0.93. What is the ratio of the Amount of CO2 emissions(kg per 2005 US$ of GDP) in Gambia, The in 1996 to that in 2000?
Ensure brevity in your answer.  0.96. What is the ratio of the Amount of CO2 emissions(kg per 2005 US$ of GDP) of Ghana in 1996 to that in 2000?
Keep it short and to the point. 1.08. What is the ratio of the Amount of CO2 emissions(kg per 2005 US$ of GDP) in Comoros in 1996 to that in 2001?
Provide a succinct answer. 0.91. What is the ratio of the Amount of CO2 emissions(kg per 2005 US$ of GDP) of Ghana in 1996 to that in 2001?
Provide a succinct answer. 1.02. What is the ratio of the Amount of CO2 emissions(kg per 2005 US$ of GDP) in Comoros in 1996 to that in 2002?
Your answer should be very brief. 0.9. What is the ratio of the Amount of CO2 emissions(kg per 2005 US$ of GDP) of Gambia, The in 1996 to that in 2002?
Offer a terse response. 0.86. What is the ratio of the Amount of CO2 emissions(kg per 2005 US$ of GDP) in Ghana in 1996 to that in 2002?
Make the answer very short. 1. What is the ratio of the Amount of CO2 emissions(kg per 2005 US$ of GDP) of Comoros in 1996 to that in 2003?
Offer a very short reply. 0.85. What is the ratio of the Amount of CO2 emissions(kg per 2005 US$ of GDP) of Gambia, The in 1996 to that in 2003?
Offer a very short reply. 0.91. What is the ratio of the Amount of CO2 emissions(kg per 2005 US$ of GDP) of Ghana in 1996 to that in 2003?
Give a very brief answer. 1.02. What is the ratio of the Amount of CO2 emissions(kg per 2005 US$ of GDP) in Comoros in 1997 to that in 1998?
Offer a terse response. 0.91. What is the ratio of the Amount of CO2 emissions(kg per 2005 US$ of GDP) of Gambia, The in 1997 to that in 1998?
Your response must be concise. 0.95. What is the ratio of the Amount of CO2 emissions(kg per 2005 US$ of GDP) in Ghana in 1997 to that in 1998?
Offer a very short reply. 1.05. What is the ratio of the Amount of CO2 emissions(kg per 2005 US$ of GDP) in Comoros in 1997 to that in 1999?
Ensure brevity in your answer.  0.84. What is the ratio of the Amount of CO2 emissions(kg per 2005 US$ of GDP) of Gambia, The in 1997 to that in 1999?
Ensure brevity in your answer.  0.93. What is the ratio of the Amount of CO2 emissions(kg per 2005 US$ of GDP) in Ghana in 1997 to that in 1999?
Provide a succinct answer. 1.07. What is the ratio of the Amount of CO2 emissions(kg per 2005 US$ of GDP) in Comoros in 1997 to that in 2000?
Your answer should be very brief. 0.9. What is the ratio of the Amount of CO2 emissions(kg per 2005 US$ of GDP) in Gambia, The in 1997 to that in 2000?
Provide a succinct answer. 0.91. What is the ratio of the Amount of CO2 emissions(kg per 2005 US$ of GDP) in Ghana in 1997 to that in 2000?
Offer a terse response. 1.15. What is the ratio of the Amount of CO2 emissions(kg per 2005 US$ of GDP) of Comoros in 1997 to that in 2001?
Offer a terse response. 0.88. What is the ratio of the Amount of CO2 emissions(kg per 2005 US$ of GDP) in Gambia, The in 1997 to that in 2001?
Provide a short and direct response. 0.94. What is the ratio of the Amount of CO2 emissions(kg per 2005 US$ of GDP) of Ghana in 1997 to that in 2001?
Offer a very short reply. 1.09. What is the ratio of the Amount of CO2 emissions(kg per 2005 US$ of GDP) of Comoros in 1997 to that in 2002?
Offer a very short reply. 0.86. What is the ratio of the Amount of CO2 emissions(kg per 2005 US$ of GDP) in Gambia, The in 1997 to that in 2002?
Keep it short and to the point. 0.82. What is the ratio of the Amount of CO2 emissions(kg per 2005 US$ of GDP) of Ghana in 1997 to that in 2002?
Offer a very short reply. 1.06. What is the ratio of the Amount of CO2 emissions(kg per 2005 US$ of GDP) of Comoros in 1997 to that in 2003?
Offer a very short reply. 0.82. What is the ratio of the Amount of CO2 emissions(kg per 2005 US$ of GDP) in Gambia, The in 1997 to that in 2003?
Your answer should be very brief. 0.87. What is the ratio of the Amount of CO2 emissions(kg per 2005 US$ of GDP) in Ghana in 1997 to that in 2003?
Provide a succinct answer. 1.09. What is the ratio of the Amount of CO2 emissions(kg per 2005 US$ of GDP) of Comoros in 1998 to that in 1999?
Provide a succinct answer. 0.93. What is the ratio of the Amount of CO2 emissions(kg per 2005 US$ of GDP) in Gambia, The in 1998 to that in 1999?
Offer a terse response. 0.97. What is the ratio of the Amount of CO2 emissions(kg per 2005 US$ of GDP) of Ghana in 1998 to that in 1999?
Your response must be concise. 1.02. What is the ratio of the Amount of CO2 emissions(kg per 2005 US$ of GDP) in Comoros in 1998 to that in 2000?
Your response must be concise. 0.98. What is the ratio of the Amount of CO2 emissions(kg per 2005 US$ of GDP) of Gambia, The in 1998 to that in 2000?
Offer a terse response. 0.96. What is the ratio of the Amount of CO2 emissions(kg per 2005 US$ of GDP) of Ghana in 1998 to that in 2000?
Provide a short and direct response. 1.1. What is the ratio of the Amount of CO2 emissions(kg per 2005 US$ of GDP) of Comoros in 1998 to that in 2001?
Offer a terse response. 0.96. What is the ratio of the Amount of CO2 emissions(kg per 2005 US$ of GDP) of Gambia, The in 1998 to that in 2001?
Make the answer very short. 0.99. What is the ratio of the Amount of CO2 emissions(kg per 2005 US$ of GDP) in Ghana in 1998 to that in 2001?
Make the answer very short. 1.04. What is the ratio of the Amount of CO2 emissions(kg per 2005 US$ of GDP) of Comoros in 1998 to that in 2002?
Give a very brief answer. 0.95. What is the ratio of the Amount of CO2 emissions(kg per 2005 US$ of GDP) of Gambia, The in 1998 to that in 2002?
Provide a succinct answer. 0.86. What is the ratio of the Amount of CO2 emissions(kg per 2005 US$ of GDP) in Ghana in 1998 to that in 2002?
Keep it short and to the point. 1.01. What is the ratio of the Amount of CO2 emissions(kg per 2005 US$ of GDP) in Comoros in 1998 to that in 2003?
Make the answer very short. 0.89. What is the ratio of the Amount of CO2 emissions(kg per 2005 US$ of GDP) in Gambia, The in 1998 to that in 2003?
Give a very brief answer. 0.91. What is the ratio of the Amount of CO2 emissions(kg per 2005 US$ of GDP) of Ghana in 1998 to that in 2003?
Offer a terse response. 1.04. What is the ratio of the Amount of CO2 emissions(kg per 2005 US$ of GDP) in Comoros in 1999 to that in 2000?
Offer a terse response. 1.06. What is the ratio of the Amount of CO2 emissions(kg per 2005 US$ of GDP) of Gambia, The in 1999 to that in 2000?
Your response must be concise. 0.98. What is the ratio of the Amount of CO2 emissions(kg per 2005 US$ of GDP) in Ghana in 1999 to that in 2000?
Your response must be concise. 1.08. What is the ratio of the Amount of CO2 emissions(kg per 2005 US$ of GDP) in Comoros in 1999 to that in 2001?
Offer a very short reply. 1.04. What is the ratio of the Amount of CO2 emissions(kg per 2005 US$ of GDP) of Gambia, The in 1999 to that in 2001?
Your answer should be compact. 1.01. What is the ratio of the Amount of CO2 emissions(kg per 2005 US$ of GDP) of Ghana in 1999 to that in 2001?
Provide a short and direct response. 1.02. What is the ratio of the Amount of CO2 emissions(kg per 2005 US$ of GDP) of Comoros in 1999 to that in 2002?
Keep it short and to the point. 1.02. What is the ratio of the Amount of CO2 emissions(kg per 2005 US$ of GDP) in Gambia, The in 1999 to that in 2002?
Provide a succinct answer. 0.88. What is the ratio of the Amount of CO2 emissions(kg per 2005 US$ of GDP) in Ghana in 1999 to that in 2002?
Ensure brevity in your answer.  0.99. What is the ratio of the Amount of CO2 emissions(kg per 2005 US$ of GDP) in Comoros in 1999 to that in 2003?
Offer a terse response. 0.97. What is the ratio of the Amount of CO2 emissions(kg per 2005 US$ of GDP) of Gambia, The in 1999 to that in 2003?
Provide a succinct answer. 0.94. What is the ratio of the Amount of CO2 emissions(kg per 2005 US$ of GDP) in Ghana in 1999 to that in 2003?
Provide a succinct answer. 1.02. What is the ratio of the Amount of CO2 emissions(kg per 2005 US$ of GDP) of Comoros in 2000 to that in 2001?
Your answer should be very brief. 0.98. What is the ratio of the Amount of CO2 emissions(kg per 2005 US$ of GDP) in Gambia, The in 2000 to that in 2001?
Your answer should be compact. 1.03. What is the ratio of the Amount of CO2 emissions(kg per 2005 US$ of GDP) of Ghana in 2000 to that in 2001?
Keep it short and to the point. 0.95. What is the ratio of the Amount of CO2 emissions(kg per 2005 US$ of GDP) in Comoros in 2000 to that in 2002?
Your response must be concise. 0.96. What is the ratio of the Amount of CO2 emissions(kg per 2005 US$ of GDP) of Gambia, The in 2000 to that in 2002?
Ensure brevity in your answer.  0.89. What is the ratio of the Amount of CO2 emissions(kg per 2005 US$ of GDP) in Ghana in 2000 to that in 2002?
Your response must be concise. 0.92. What is the ratio of the Amount of CO2 emissions(kg per 2005 US$ of GDP) of Comoros in 2000 to that in 2003?
Your answer should be compact. 0.91. What is the ratio of the Amount of CO2 emissions(kg per 2005 US$ of GDP) of Gambia, The in 2000 to that in 2003?
Keep it short and to the point. 0.95. What is the ratio of the Amount of CO2 emissions(kg per 2005 US$ of GDP) in Ghana in 2000 to that in 2003?
Give a very brief answer. 0.94. What is the ratio of the Amount of CO2 emissions(kg per 2005 US$ of GDP) in Comoros in 2001 to that in 2002?
Make the answer very short. 0.98. What is the ratio of the Amount of CO2 emissions(kg per 2005 US$ of GDP) in Gambia, The in 2001 to that in 2002?
Keep it short and to the point. 0.87. What is the ratio of the Amount of CO2 emissions(kg per 2005 US$ of GDP) of Ghana in 2001 to that in 2002?
Your response must be concise. 0.97. What is the ratio of the Amount of CO2 emissions(kg per 2005 US$ of GDP) of Comoros in 2001 to that in 2003?
Make the answer very short. 0.93. What is the ratio of the Amount of CO2 emissions(kg per 2005 US$ of GDP) in Gambia, The in 2001 to that in 2003?
Offer a terse response. 0.93. What is the ratio of the Amount of CO2 emissions(kg per 2005 US$ of GDP) in Ghana in 2001 to that in 2003?
Offer a very short reply. 1. What is the ratio of the Amount of CO2 emissions(kg per 2005 US$ of GDP) in Comoros in 2002 to that in 2003?
Keep it short and to the point. 0.95. What is the ratio of the Amount of CO2 emissions(kg per 2005 US$ of GDP) in Gambia, The in 2002 to that in 2003?
Your answer should be compact. 1.07. What is the ratio of the Amount of CO2 emissions(kg per 2005 US$ of GDP) of Ghana in 2002 to that in 2003?
Your answer should be compact. 1.02. What is the difference between the highest and the second highest Amount of CO2 emissions(kg per 2005 US$ of GDP) in Comoros?
Keep it short and to the point. 0.01. What is the difference between the highest and the second highest Amount of CO2 emissions(kg per 2005 US$ of GDP) of Gambia, The?
Your answer should be compact. 0.04. What is the difference between the highest and the second highest Amount of CO2 emissions(kg per 2005 US$ of GDP) in Ghana?
Make the answer very short. 0.04. What is the difference between the highest and the lowest Amount of CO2 emissions(kg per 2005 US$ of GDP) of Comoros?
Provide a short and direct response. 0.05. What is the difference between the highest and the lowest Amount of CO2 emissions(kg per 2005 US$ of GDP) in Gambia, The?
Give a very brief answer. 0.11. What is the difference between the highest and the lowest Amount of CO2 emissions(kg per 2005 US$ of GDP) in Ghana?
Ensure brevity in your answer.  0.11. 